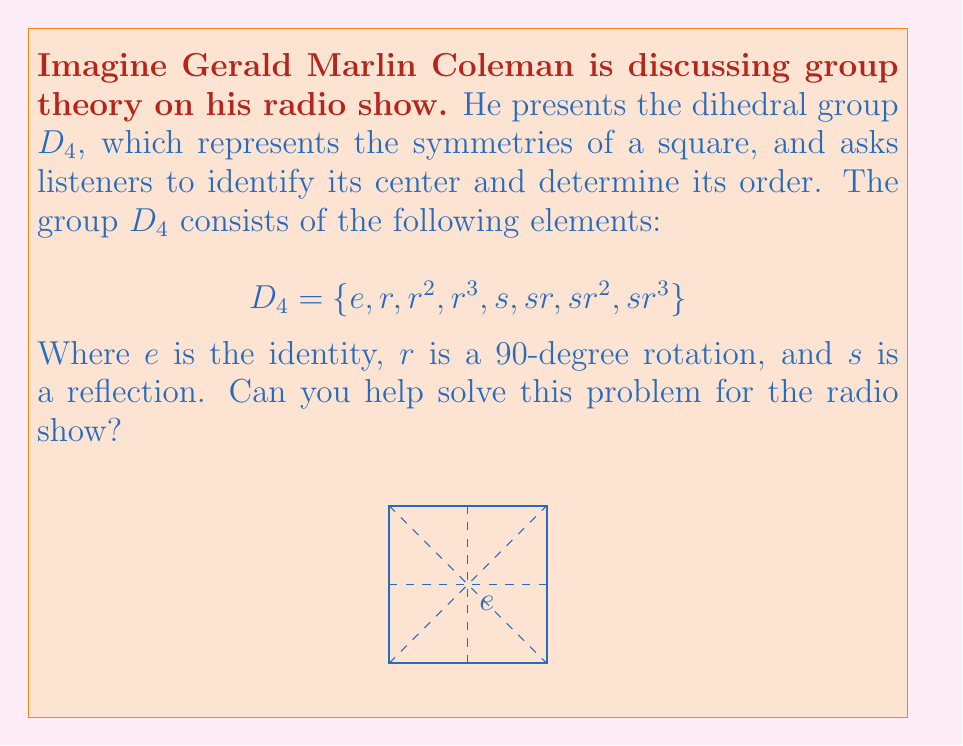Can you answer this question? Let's approach this step-by-step:

1) The center of a group $G$, denoted $Z(G)$, is the set of all elements that commute with every element in the group. In other words:

   $Z(G) = \{z \in G : zg = gz \text{ for all } g \in G\}$

2) We need to check which elements commute with all others in $D_4$. Let's start with the identity $e$:
   - $e$ commutes with all elements, so it's in the center.

3) Now, let's check the rotations:
   - $r$ doesn't commute with $s$, because $rs \neq sr$
   - The same is true for $r^3$

4) However, $r^2$ (a 180-degree rotation) does commute with all elements:
   - $r^2r = rr^2$
   - $r^2s = sr^2$
   - So $r^2$ is in the center.

5) The reflections $s$, $sr$, $sr^2$, and $sr^3$ don't commute with the rotations, so they're not in the center.

6) Therefore, the center of $D_4$ consists of $\{e, r^2\}$.

7) The order of the center is the number of elements in it, which is 2.
Answer: $Z(D_4) = \{e, r^2\}$, order = 2 